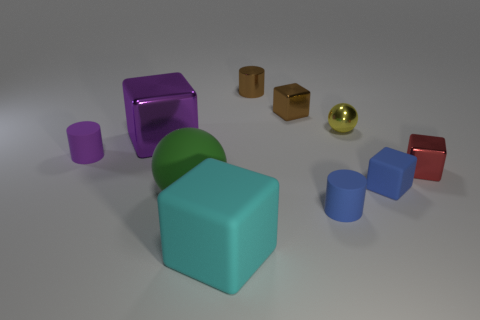Subtract all cyan blocks. How many blocks are left? 4 Subtract all purple shiny cubes. How many cubes are left? 4 Subtract all yellow cubes. Subtract all blue cylinders. How many cubes are left? 5 Subtract all cylinders. How many objects are left? 7 Add 3 green rubber things. How many green rubber things exist? 4 Subtract 0 purple spheres. How many objects are left? 10 Subtract all big cyan things. Subtract all big matte balls. How many objects are left? 8 Add 6 small metal cylinders. How many small metal cylinders are left? 7 